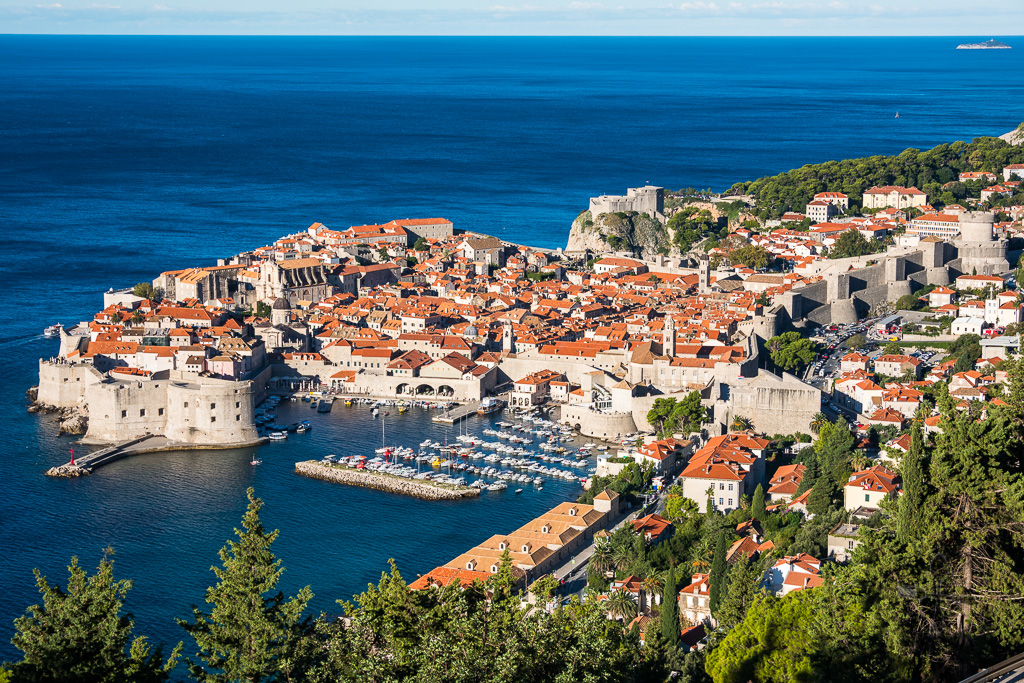Can you tell me about the architectural styles found within the walls of Dubrovnik? Within the ancient walls of Dubrovnik, a rich tapestry of architectural styles emerges, reflecting the city's diverse history. Predominantly, the city showcases Gothic, Renaissance, and Baroque styles. The Gothic architecture is evident in structures like the Rector’s Palace with its elaborate stonework and pointed arches. Renaissance influences shine through in the harmoniously proportioned Sponza Palace and the serene cloisters of the Franciscan Monastery. The Baroque style became prominent after the devastating earthquake of 1667, epitomized by the grand St. Blaise's Church and the Jesuit Staircase. This architectural diversity is a testament to the city's resilience and its absorption of various cultural influences over centuries. 